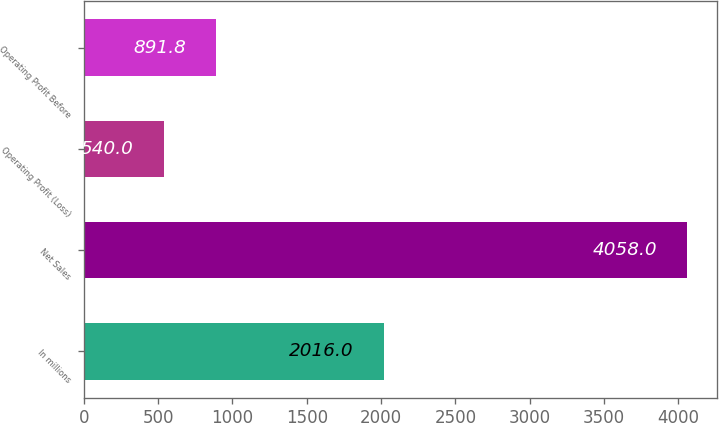<chart> <loc_0><loc_0><loc_500><loc_500><bar_chart><fcel>In millions<fcel>Net Sales<fcel>Operating Profit (Loss)<fcel>Operating Profit Before<nl><fcel>2016<fcel>4058<fcel>540<fcel>891.8<nl></chart> 